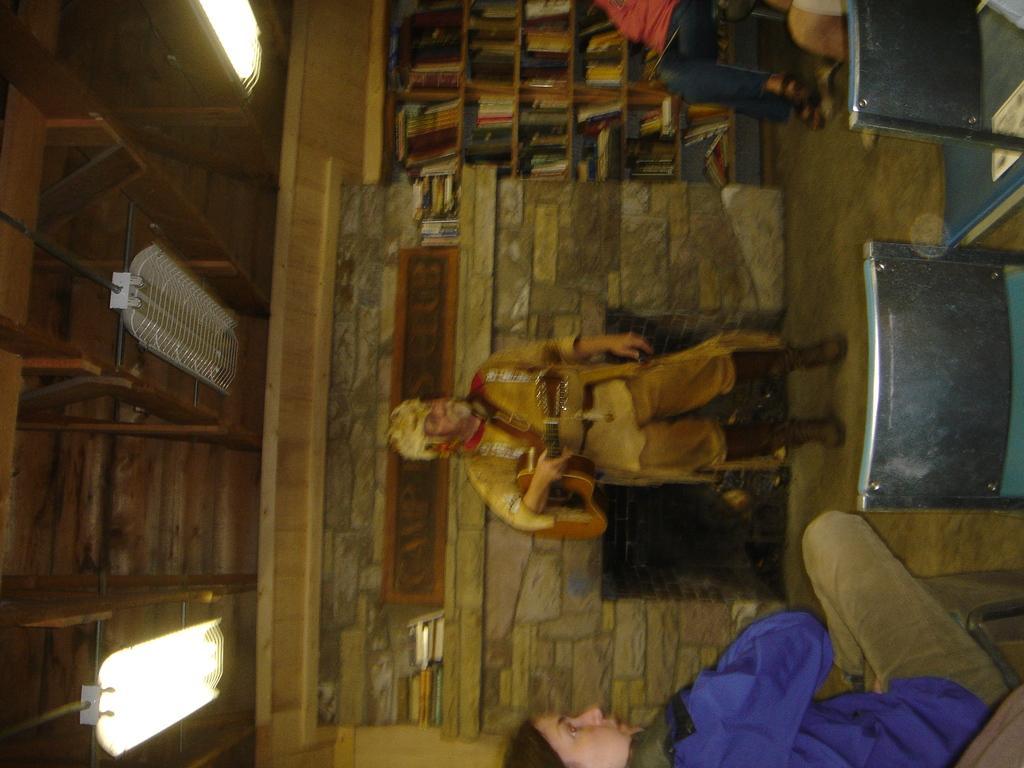Can you describe this image briefly? In this image we can see a man holding the guitar and standing on the floor. We can also see a woman sitting on the chair. We can also see the two empty chairs. In the background there is also another person sitting. Image also consists of many books placed on the racks. At the top we can see the roof and also the lights. We can also see the fireplace. 